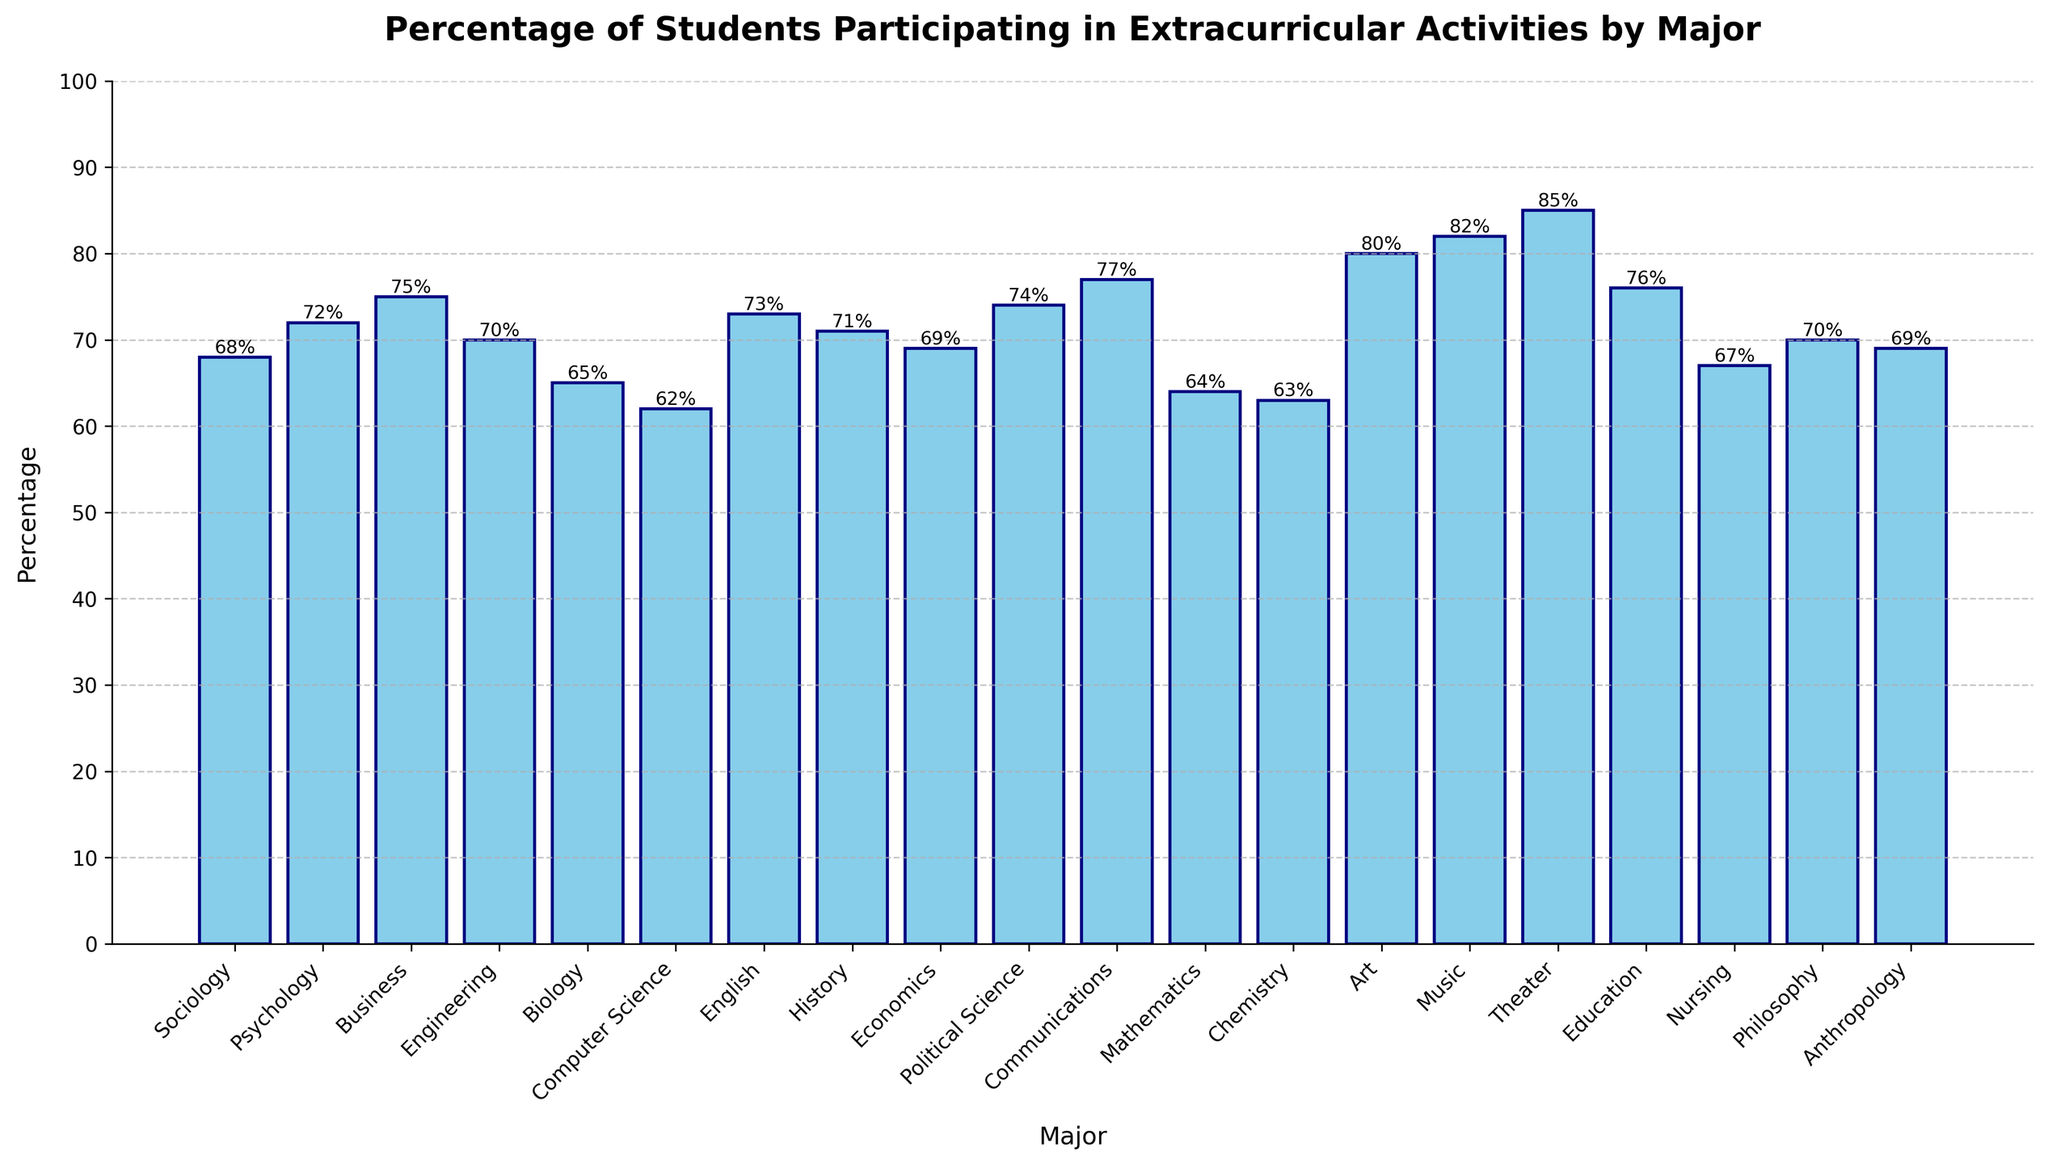what is the highest percentage value? The highest percentage in the chart corresponds to the Theater major. By looking at the height of the bars, Theater has the tallest bar, indicating the highest participation rate.
Answer: 85% Which major has a percentage of 68%? By identifying the bar with the height of 68%, it's clear that it corresponds to the Sociology major.
Answer: Sociology Which two majors have participation percentages within 1% of each other? Psychology and Engineering are close with percentages of 72% and 70% respectively. By visually comparing the bars' heights, these two are nearly the same.
Answer: Psychology and Engineering What is the average percentage of participation in extracurricular activities for Art, Music, and Theater majors? First, add the percentages for Art, Music, and Theater: 80 + 82 + 85 = 247. Then, divide by the number of majors: 247 / 3 = 82.33.
Answer: 82.33% How much higher is the participation percentage for Music majors compared to Chemistry majors? Subtract the percentage for Chemistry (63%) from Music (82%): 82 - 63 = 19.
Answer: 19% Which major has the lowest participation rate, and what is that rate? The shortest bar in the chart corresponds to the Computer Science major with a percentage of 62%.
Answer: Computer Science, 62% How many majors have participation percentages of at least 70%? From the chart, tally the bars that reach or exceed 70%: Psychology, Business, Engineering, English, History, Political Science, Communications, Theater, and Education. This results in 9 majors.
Answer: 9 What is the difference in participation percentage between Communications and Sociology majors? Subtract Sociology (68%) from Communications (77%): 77 - 68 = 9.
Answer: 9% Which majors have exactly 69% participation? The majors with bars reaching 69% are Economics and Anthropology.
Answer: Economics and Anthropology Between Nursing and Education, which has a higher percentage of students in extracurricular activities? By comparing the heights of the bars, Education has a higher percentage (76%) compared to Nursing (67%).
Answer: Education 